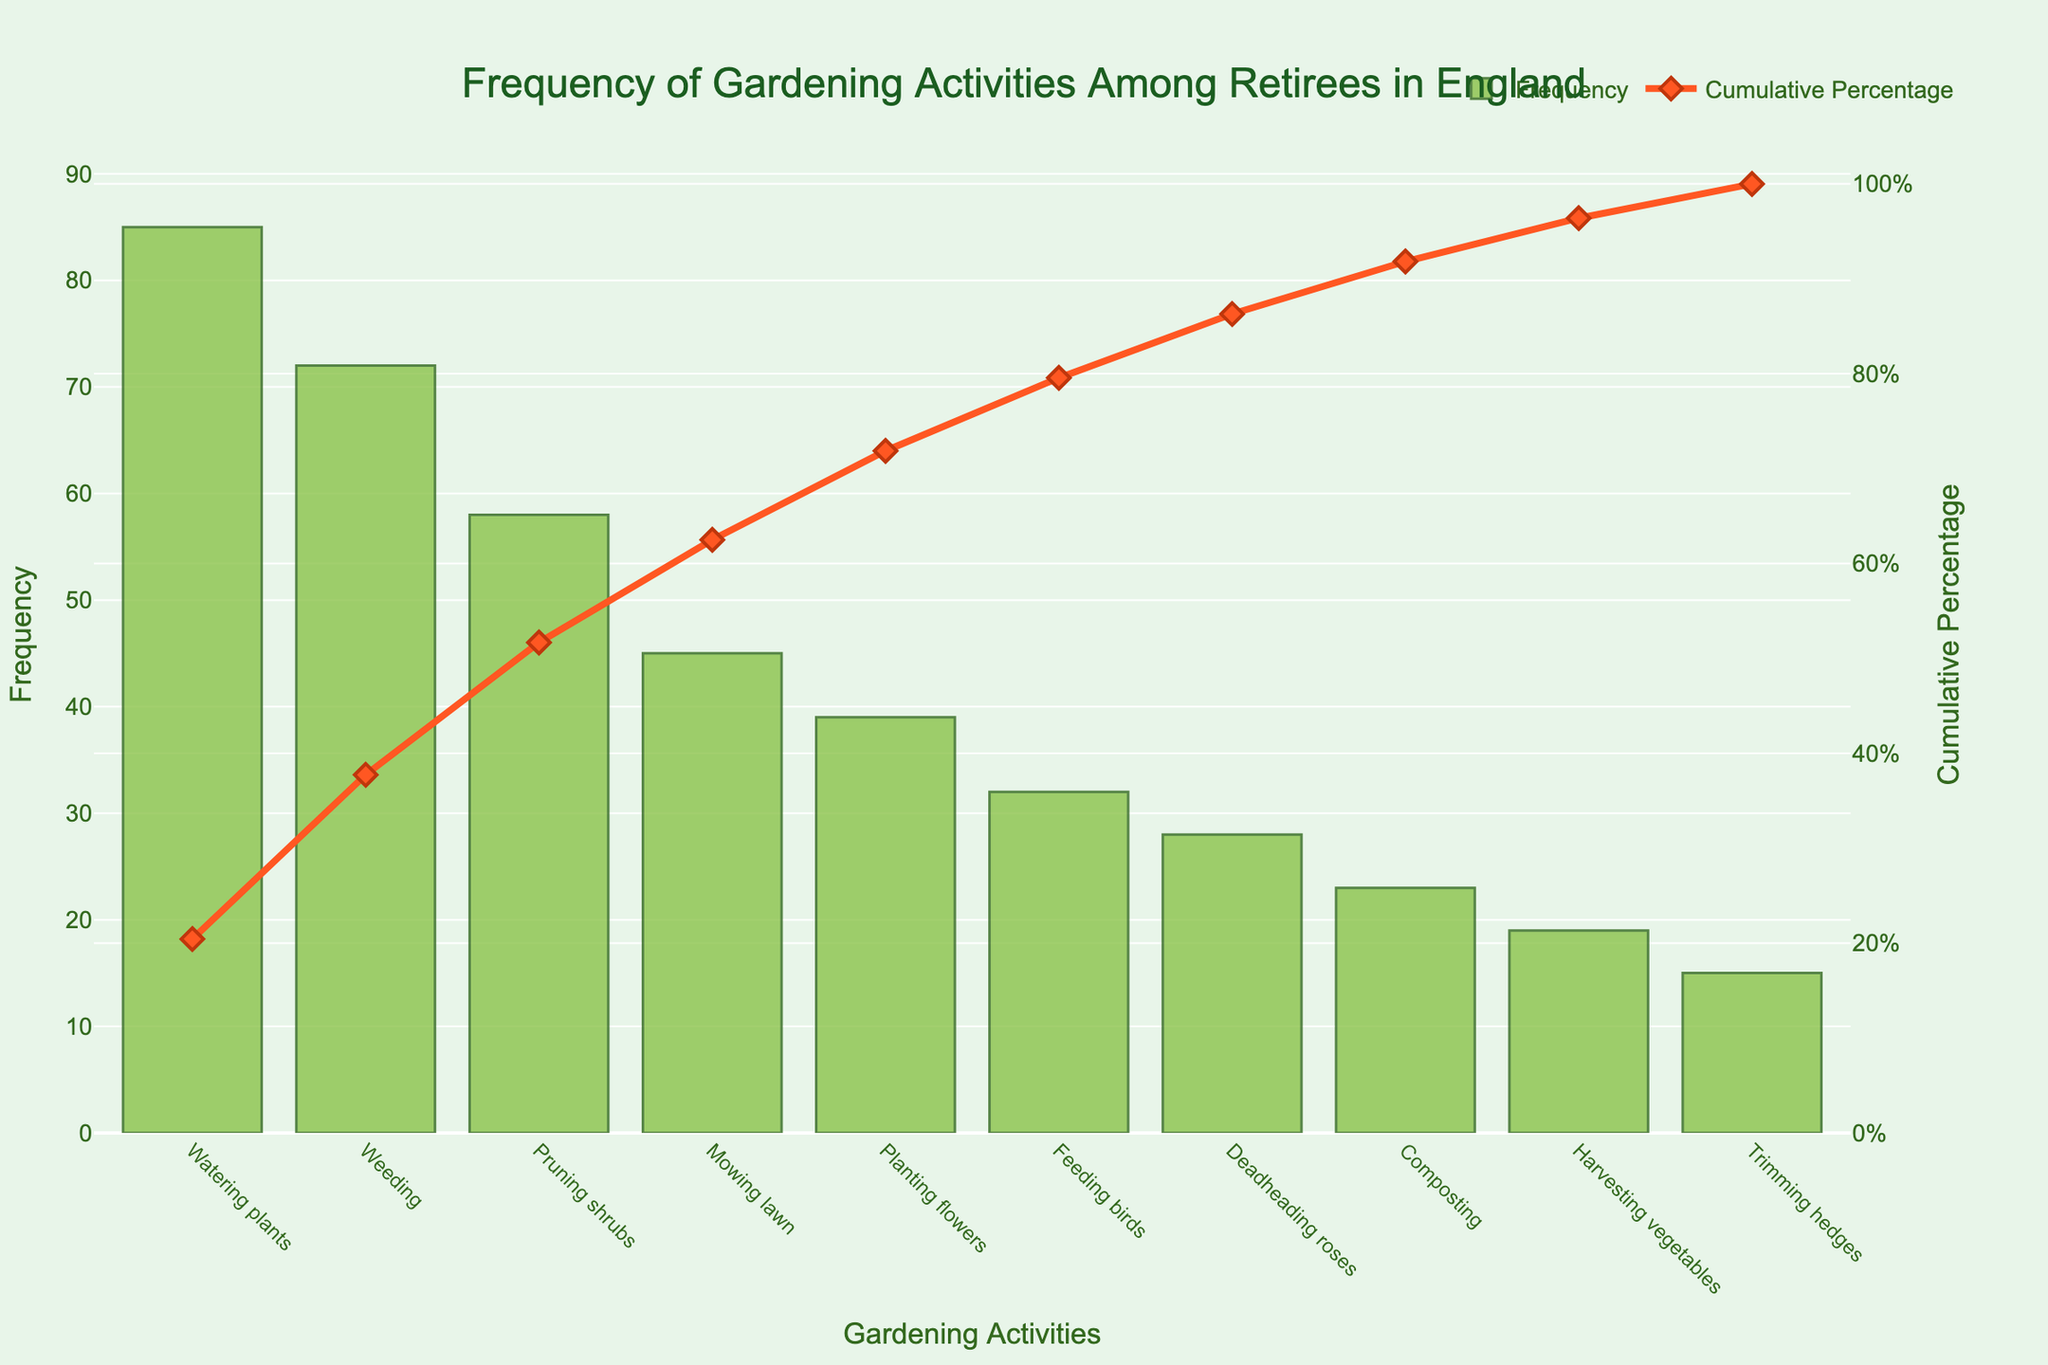1. What is the title of the chart? The title of the chart is displayed at the top and provides an overview of the content.
Answer: Frequency of Gardening Activities Among Retirees in England 2. Which gardening activity has the highest frequency? The highest bar in the chart represents the activity with the highest frequency.
Answer: Watering plants 3. How many gardening activities have a frequency higher than 50? Count the number of bars with heights representing frequencies higher than 50.
Answer: 3 4. What is the cumulative percentage for weeding? Find the point on the cumulative percentage line corresponding to 'Weeding'.
Answer: 29.2% 5. How does the frequency of mowing the lawn compare to planting flowers? Look at the heights of the bars for mowing the lawn and planting flowers and compare them.
Answer: Mowing lawn has a higher frequency than planting flowers 6. What is the total frequency of the top three activities combined? Add the frequencies of the top three activities (watering plants, weeding, pruning shrubs).
Answer: 215 7. What is the cumulative percentage for the top four activities? Add the frequencies of the top four activities, then divide by the total frequency and multiply by 100. The top four activities are watering plants, weeding, pruning shrubs, and mowing lawn.
Answer: 73.4% 8. Which activity has the lowest frequency, and what is its value? The shortest bar represents the activity with the lowest frequency.
Answer: Trimming hedges, 15 9. What is the difference in frequency between harvesting vegetables and feeding birds? Subtract the frequency of harvesting vegetables from the frequency of feeding birds.
Answer: 13 10. Which gardening activities form the 80% cumulative percentage mark? Identify the activities until the cumulative percentage line reaches or just exceeds 80%.
Answer: Watering plants, weeding, pruning shrubs, mowing lawn, planting flowers 